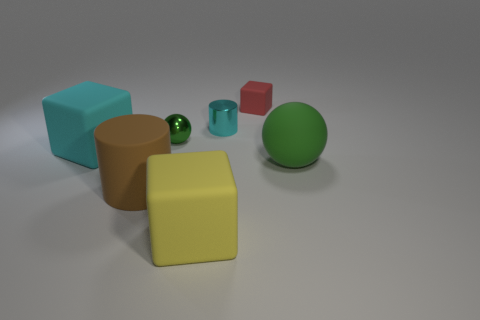Can you identify which objects are similar in color, and describe any patterns or design principles evident in their arrangement? The cyan cube and the teal cylinder exhibit similar color hues, both falling within the spectrum of cool, blue-green shades. Arrangement-wise, the objects are placed with a sense of balance and diverse geometrical representation, showcasing a simple yet effective illustration of varied forms and sizes. Could the way these objects are arranged tell us anything about the rule of thirds or visual composition techniques? Although not perfectly aligned with the rule of thirds, the placement does contribute to visual interest. The objects are arranged asymmetrically, which provides a dynamic composition as opposed to a more static, symmetrical display. This can evoke curiosity and lead the viewer's eye across the scene, exploring each object individually. 